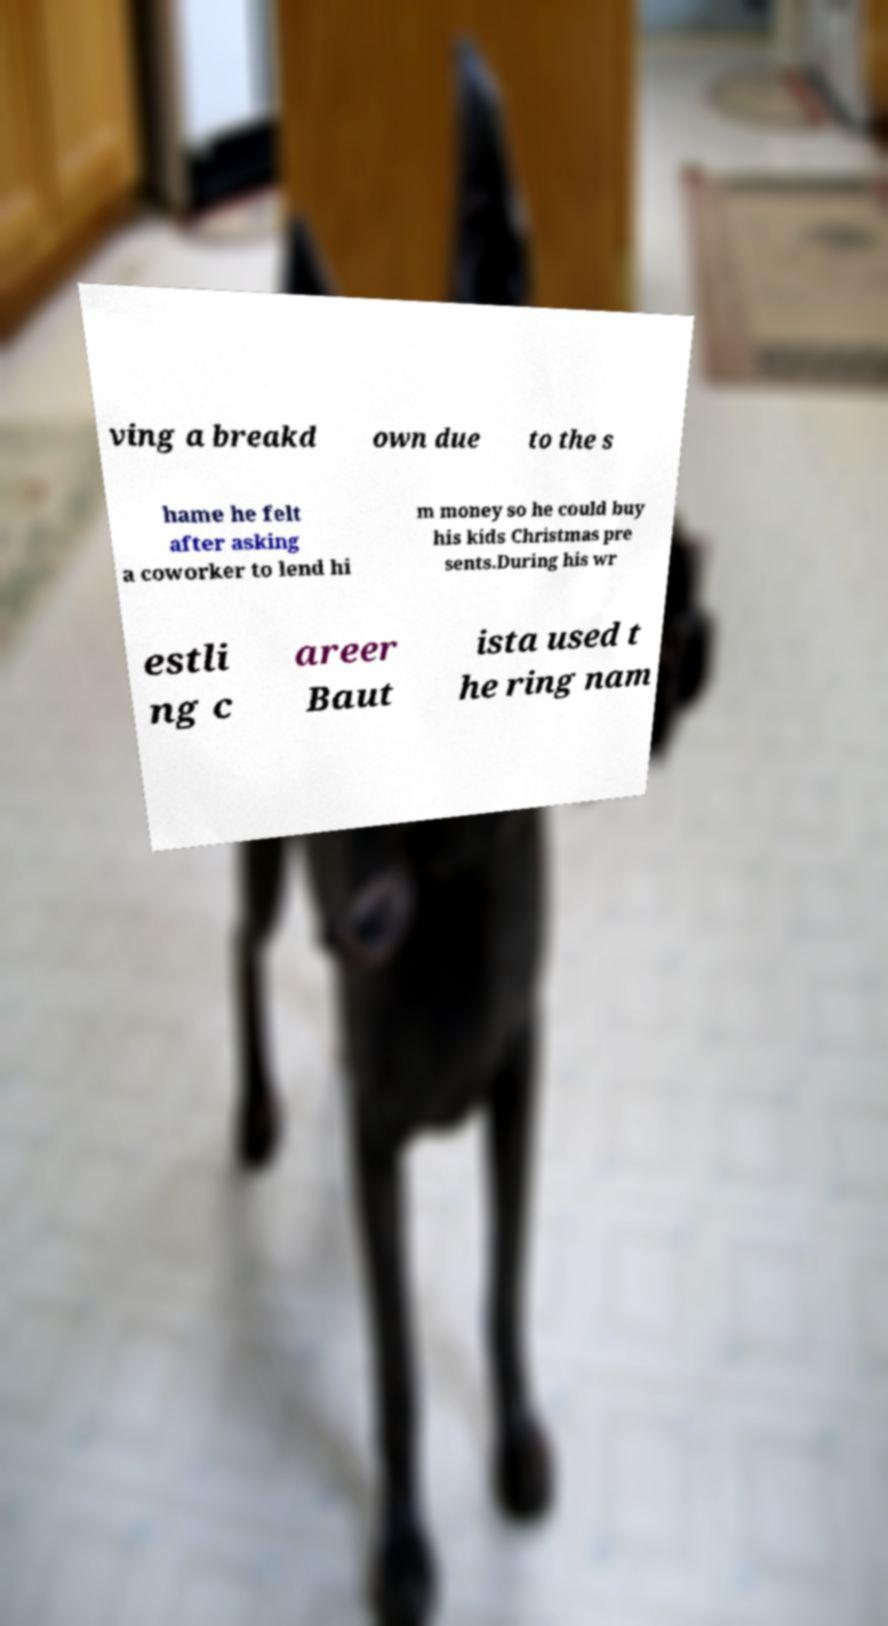There's text embedded in this image that I need extracted. Can you transcribe it verbatim? ving a breakd own due to the s hame he felt after asking a coworker to lend hi m money so he could buy his kids Christmas pre sents.During his wr estli ng c areer Baut ista used t he ring nam 